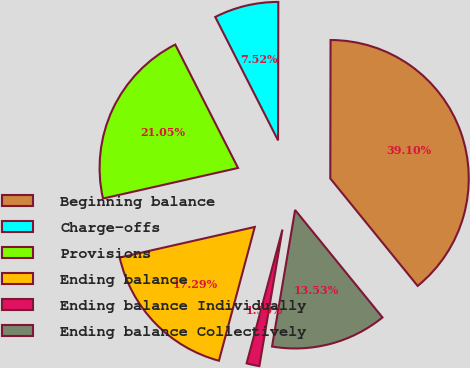Convert chart to OTSL. <chart><loc_0><loc_0><loc_500><loc_500><pie_chart><fcel>Beginning balance<fcel>Charge-offs<fcel>Provisions<fcel>Ending balance<fcel>Ending balance Individually<fcel>Ending balance Collectively<nl><fcel>39.1%<fcel>7.52%<fcel>21.05%<fcel>17.29%<fcel>1.5%<fcel>13.53%<nl></chart> 